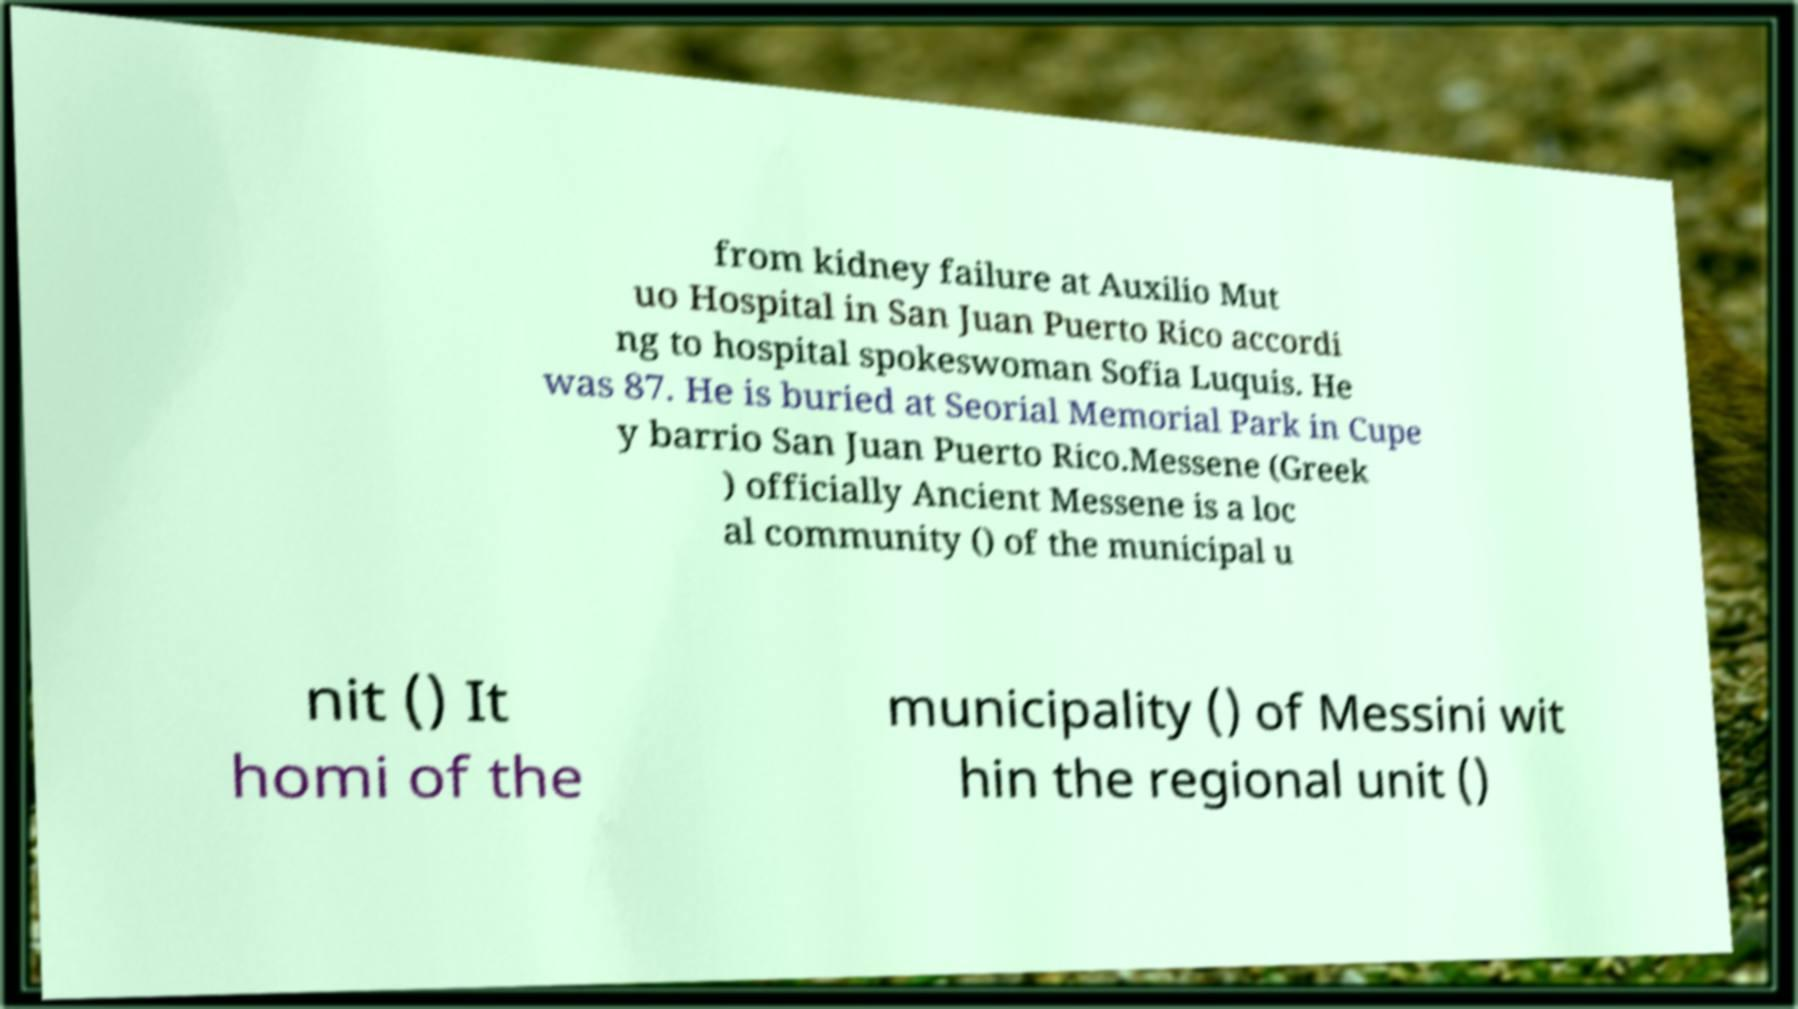Could you extract and type out the text from this image? from kidney failure at Auxilio Mut uo Hospital in San Juan Puerto Rico accordi ng to hospital spokeswoman Sofia Luquis. He was 87. He is buried at Seorial Memorial Park in Cupe y barrio San Juan Puerto Rico.Messene (Greek ) officially Ancient Messene is a loc al community () of the municipal u nit () It homi of the municipality () of Messini wit hin the regional unit () 